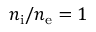Convert formula to latex. <formula><loc_0><loc_0><loc_500><loc_500>n _ { i } / n _ { e } = 1</formula> 